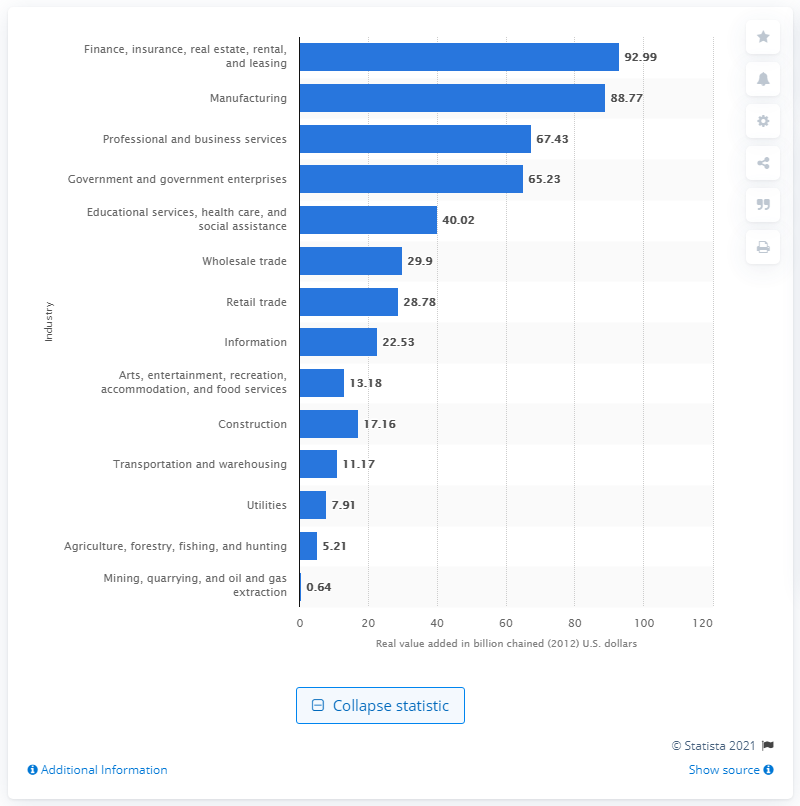Draw attention to some important aspects in this diagram. In 2012, the construction industry contributed a significant amount to the state's Gross Domestic Product (GDP) with a value of 17.16. 